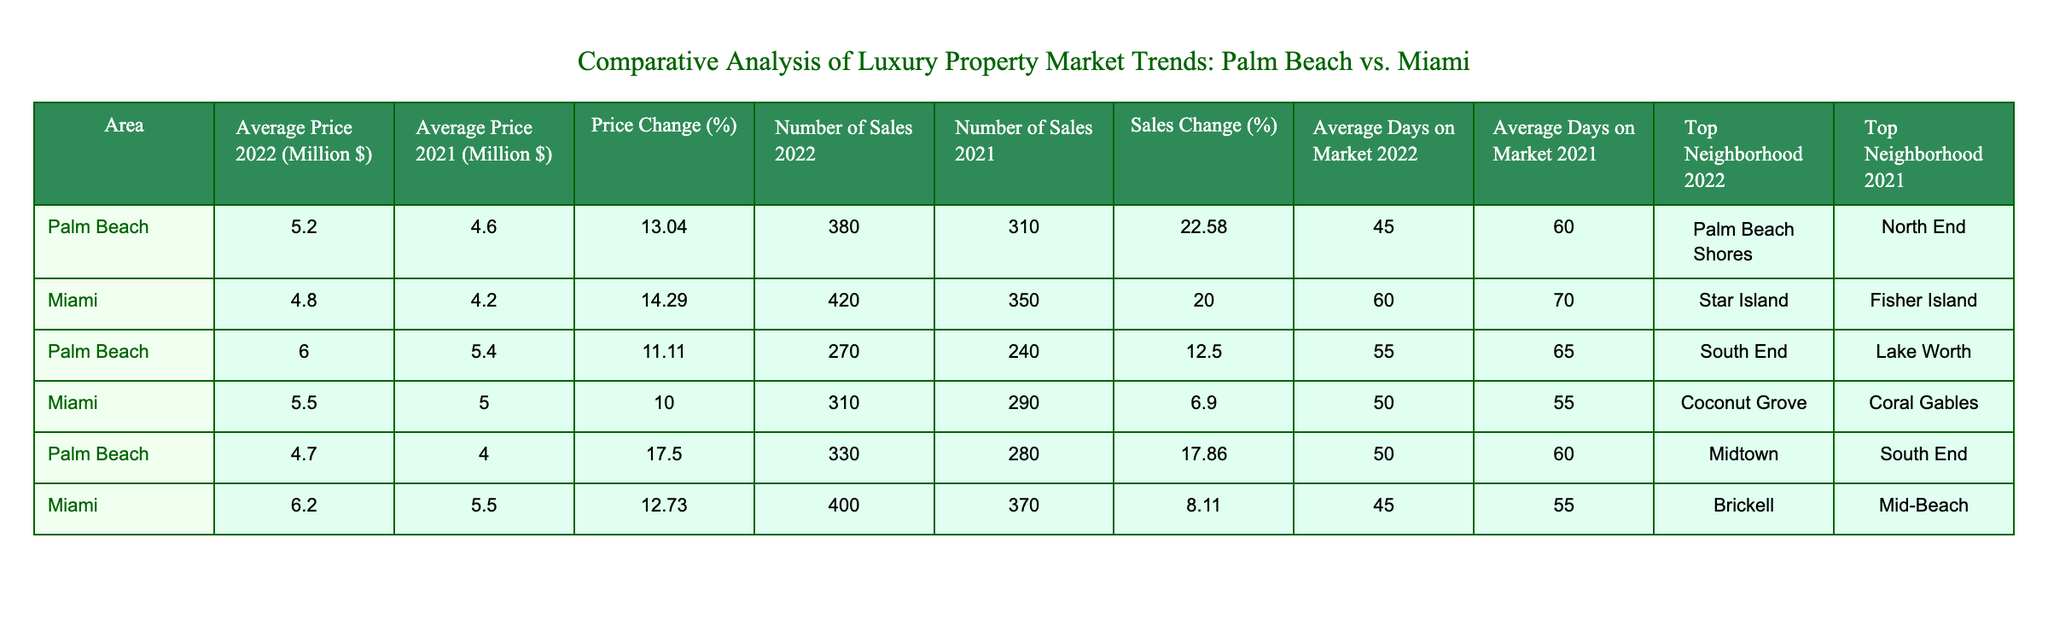What was the average price of luxury properties in Palm Beach in 2022? The table shows that the average price of luxury properties in Palm Beach in 2022 is listed as 5.2 million dollars.
Answer: 5.2 million dollars Which area had a higher number of sales in 2022, Palm Beach or Miami? In 2022, Palm Beach had 380 sales while Miami had 420 sales, indicating that Miami had a higher number of sales.
Answer: Miami What is the percentage price change for luxury properties in Palm Beach from 2021 to 2022? The table indicates a price change of 13.04% for Palm Beach from 2021 to 2022.
Answer: 13.04% Is it true that the average days on market decreased for both Palm Beach and Miami from 2021 to 2022? For Palm Beach, the average days on market decreased from 60 in 2021 to 45 in 2022. In Miami, it decreased from 70 in 2021 to 60 in 2022. Therefore, the statement is true for both areas.
Answer: Yes What is the total number of sales in both Palm Beach and Miami for 2022? Adding the number of sales in Palm Beach (380 + 270 + 330) and Miami (420 + 310 + 400) gives a total of 2,110 sales for both areas in 2022.
Answer: 2,110 sales In which neighborhood was the average price highest in Palm Beach in 2022? The neighborhoods listed for Palm Beach in 2022 are Palm Beach Shores (5.2 million), South End (6.0 million), and Midtown (4.7 million). The highest average price is in South End at 6.0 million.
Answer: South End How much did the average price of luxury properties increase in Miami from 2021 to 2022? The average price in Miami in 2021 was 4.2 million dollars, and in 2022 it was 4.8 million dollars. The increase is calculated as 4.8 - 4.2 = 0.6 million dollars.
Answer: 0.6 million dollars Which area had a higher average price in 2022, Palm Beach or Miami? The average price in Palm Beach in 2022 is 5.2 million dollars, whereas in Miami it is 4.8 million dollars. Thus, Palm Beach had a higher average price in 2022.
Answer: Palm Beach What was the average number of days on market for luxury properties in Miami in 2022? The table shows that the average number of days on market in Miami in 2022 is 60 days.
Answer: 60 days 